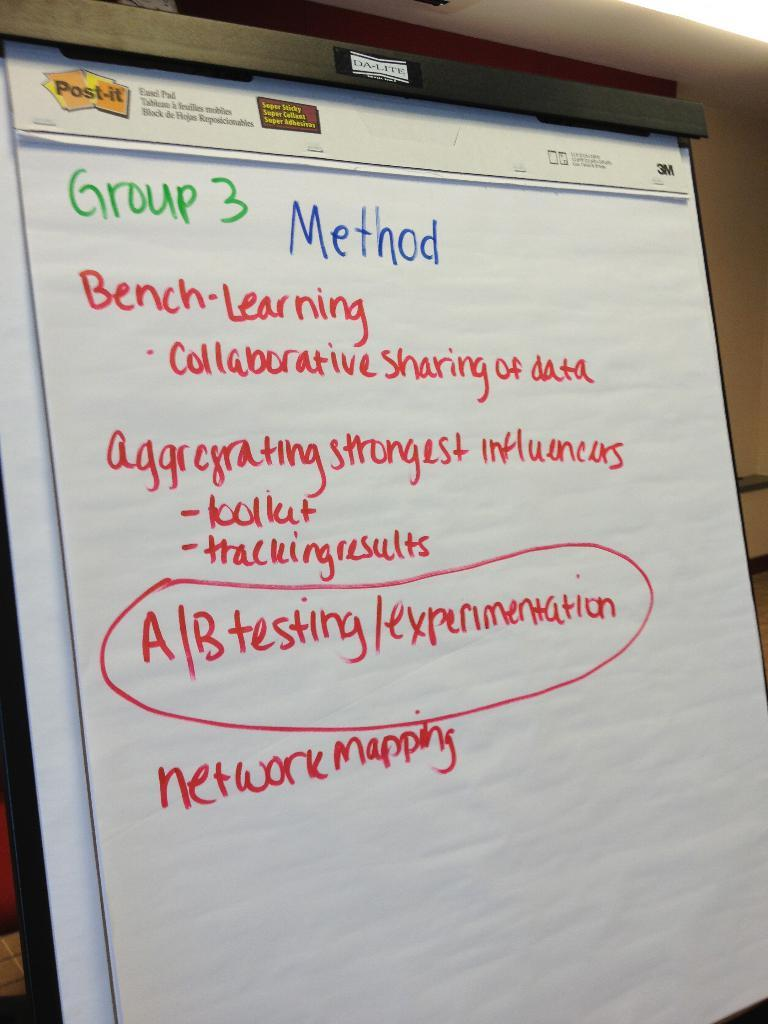<image>
Summarize the visual content of the image. A large paper note pad made by Post-it with green, blue and red text outlining Group 3's methods for work to be done. 